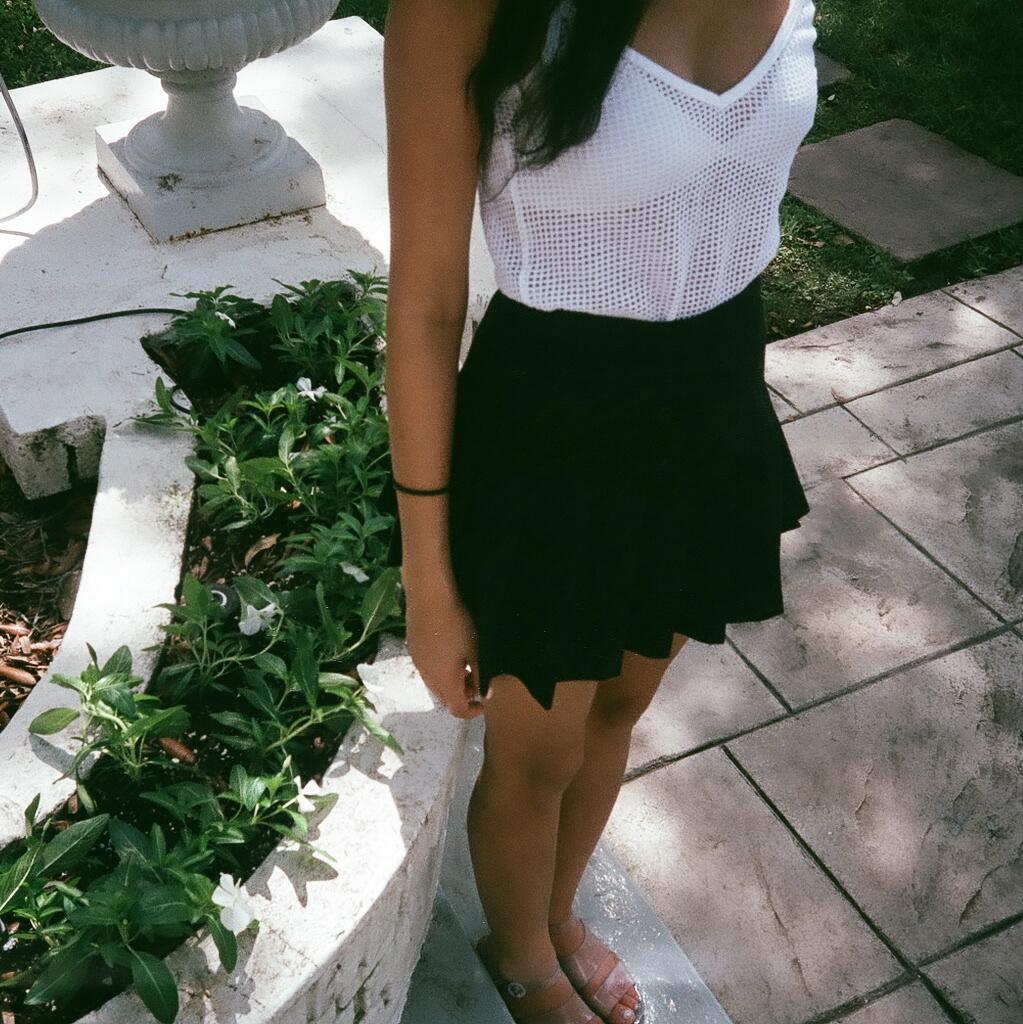Describe this image in one or two sentences. In this image, in the middle, we can see a woman standing on the staircase. On the left side, we can see a wall, plants, electric wire. On the left side, we can also see an object. On the right side, we can see green color, marble. At the bottom, we can see a grass and a land. 